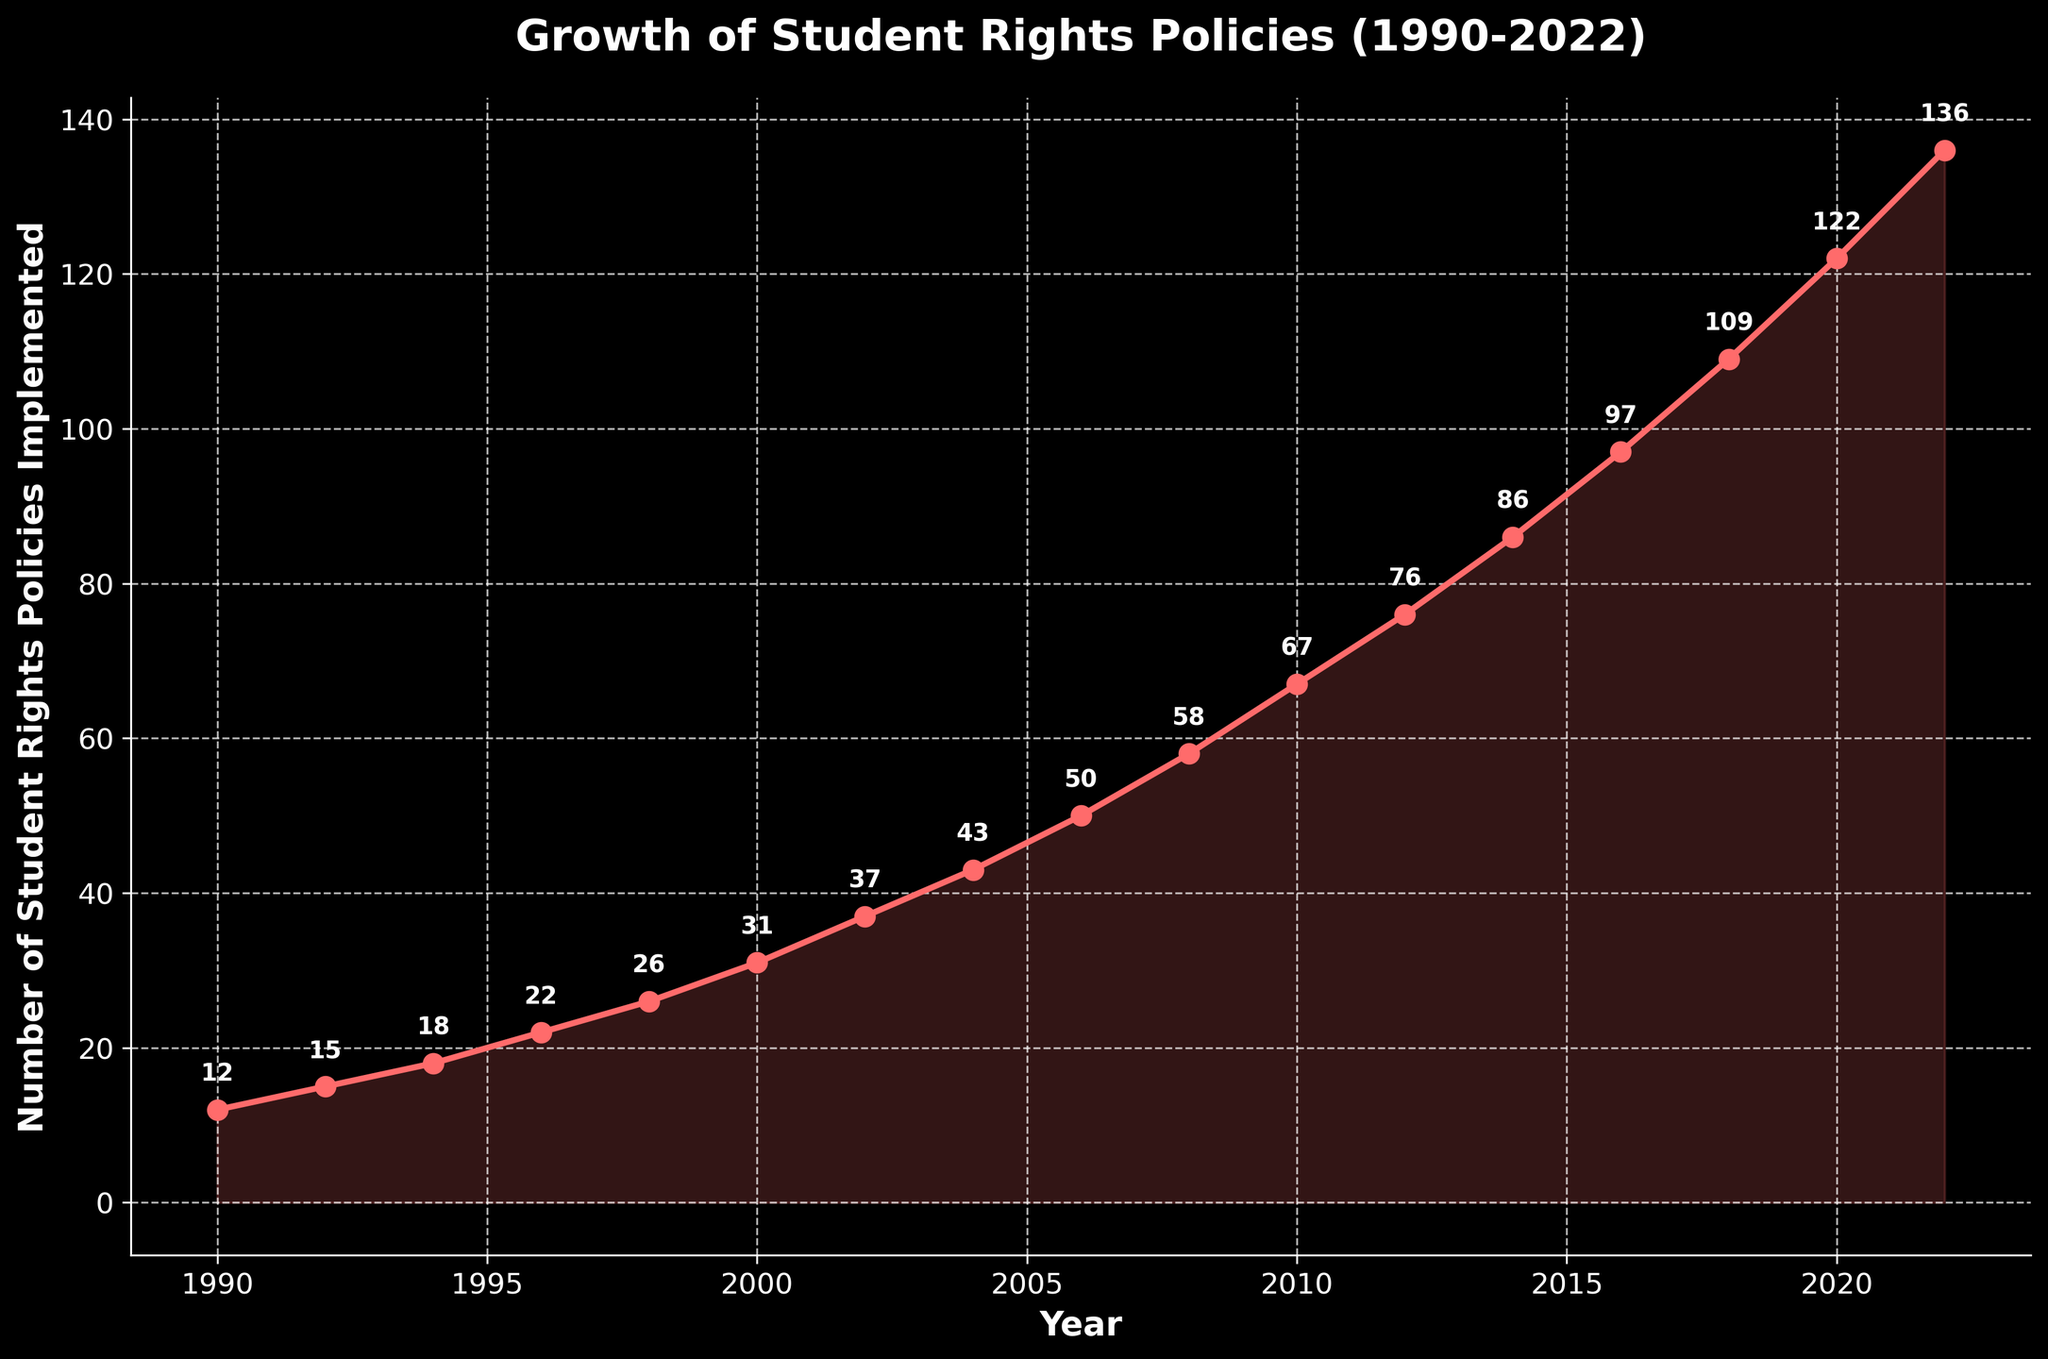What was the number of student rights policies implemented in 2000? Look at the point detailed for the year 2000 and read the labeled number of policies implemented.
Answer: 31 In which year did the number of student rights policies first exceed 100? Identify and compare the data points year by year to find the first instance where the policies exceeded 100.
Answer: 2018 What is the overall trend in the number of student rights policies implemented between 1990 and 2022? Observe the overall direction of the line graph from 1990 to 2022; it shows a continuous upward trend.
Answer: Upward Which year experienced the highest single-year increase in student rights policies implemented, and what was the increase? Calculate the difference in policies between consecutive years and identify the maximum difference.
Answer: 2008, 8 Between which two consecutive years was the implementation rate the slowest? Calculate the difference between consecutive years and find the smallest increase, which is between 1990 and 1992.
Answer: 1990 to 1992 Is the rate of implementation increasing, decreasing, or remaining steady over the years shown? Observe the steepness of the line graph, which grows steeper over time, indicating an increasing rate of implementation.
Answer: Increasing 